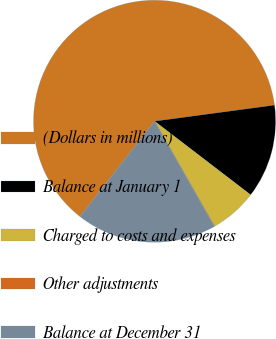Convert chart to OTSL. <chart><loc_0><loc_0><loc_500><loc_500><pie_chart><fcel>(Dollars in millions)<fcel>Balance at January 1<fcel>Charged to costs and expenses<fcel>Other adjustments<fcel>Balance at December 31<nl><fcel>62.3%<fcel>12.53%<fcel>6.31%<fcel>0.09%<fcel>18.76%<nl></chart> 